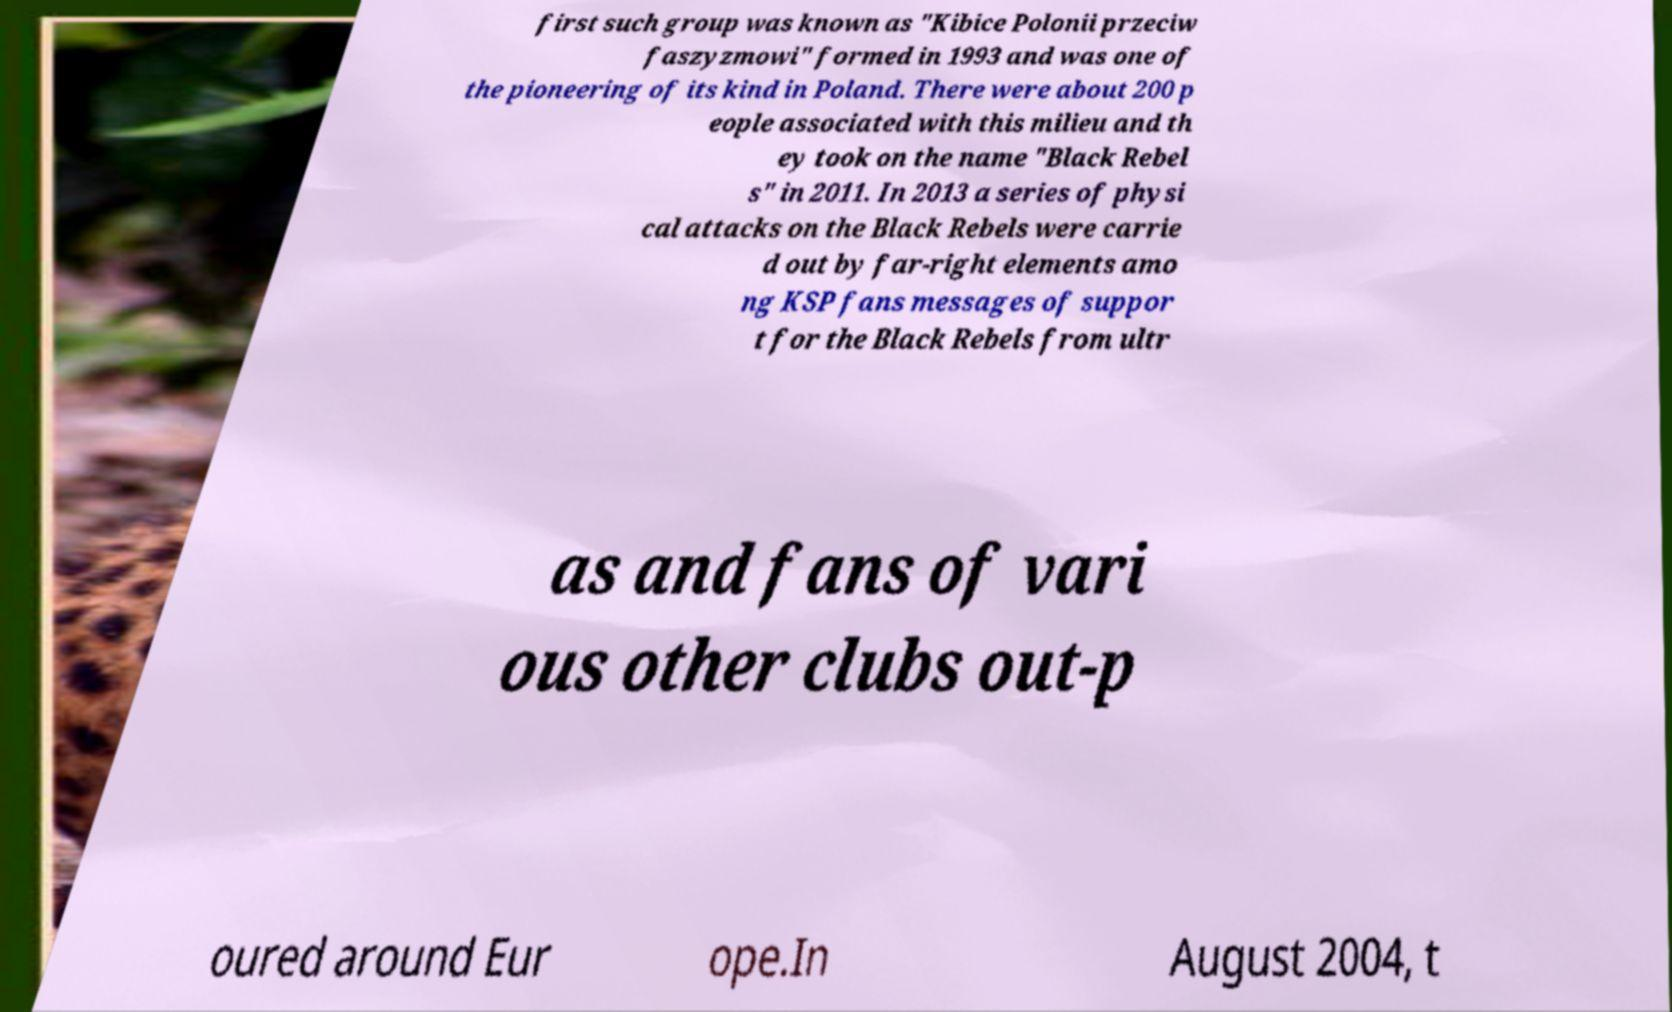There's text embedded in this image that I need extracted. Can you transcribe it verbatim? first such group was known as "Kibice Polonii przeciw faszyzmowi" formed in 1993 and was one of the pioneering of its kind in Poland. There were about 200 p eople associated with this milieu and th ey took on the name "Black Rebel s" in 2011. In 2013 a series of physi cal attacks on the Black Rebels were carrie d out by far-right elements amo ng KSP fans messages of suppor t for the Black Rebels from ultr as and fans of vari ous other clubs out-p oured around Eur ope.In August 2004, t 